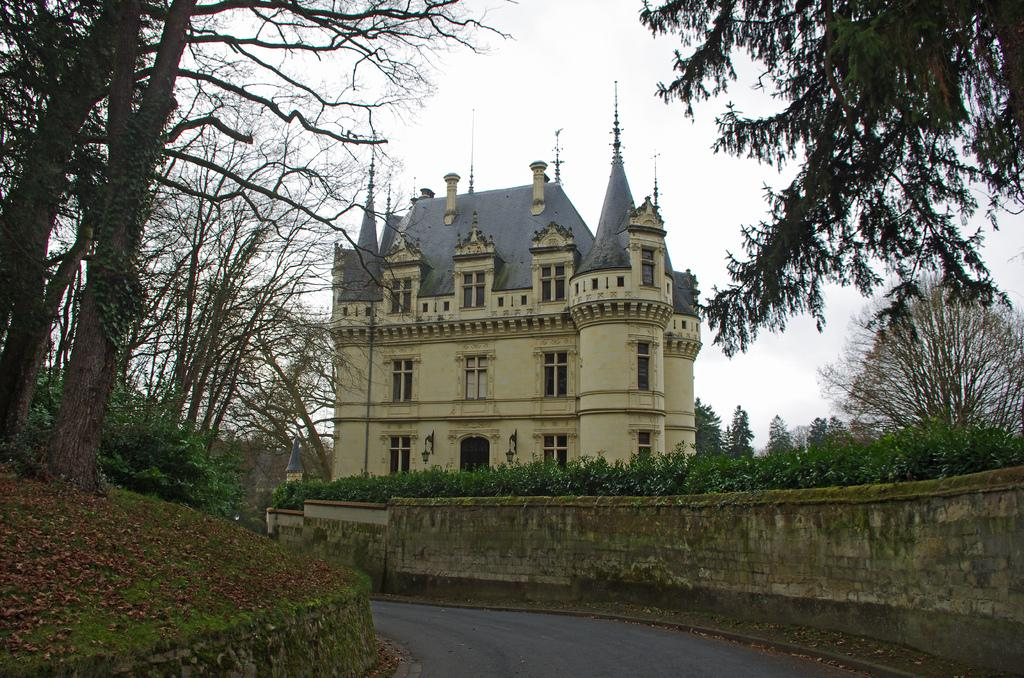What type of surface can be seen in the image? There is a road in the image. What structures are present in the image? There are walls and a building with windows in the image. What natural elements can be seen in the image? There are trees and dried leaves present in the image. What is visible in the background of the image? The sky is visible in the background of the image. What type of metal can be seen in the image? There is no metal present in the image. Can you see a cat playing with the leaves in the image? There is no cat present in the image. 